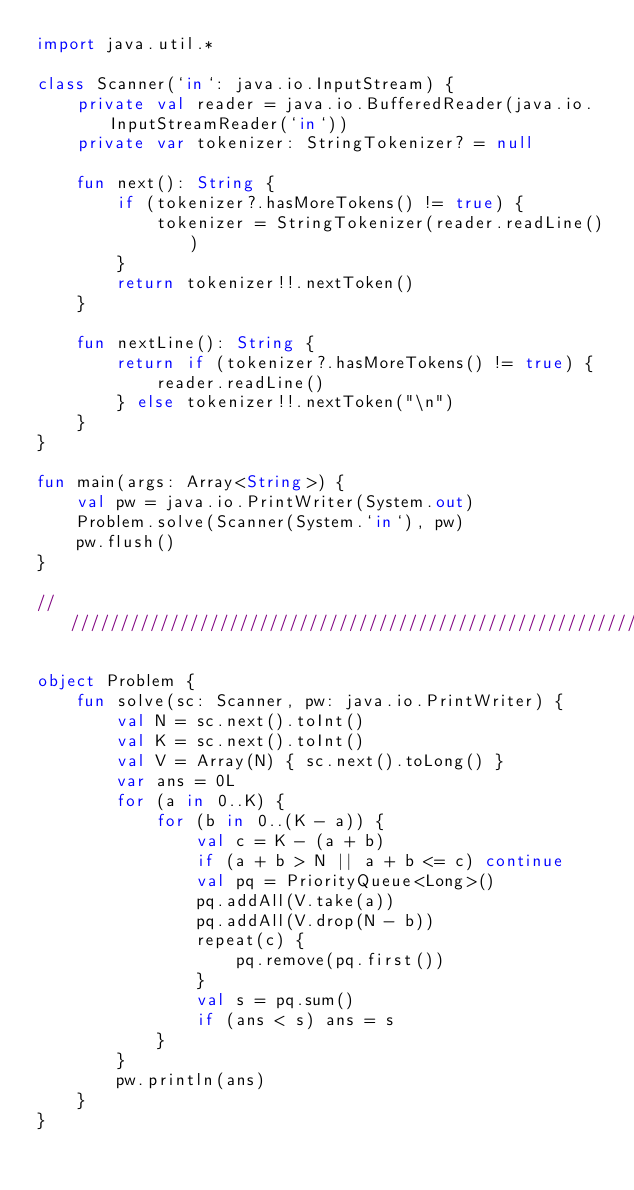<code> <loc_0><loc_0><loc_500><loc_500><_Kotlin_>import java.util.*

class Scanner(`in`: java.io.InputStream) {
    private val reader = java.io.BufferedReader(java.io.InputStreamReader(`in`))
    private var tokenizer: StringTokenizer? = null

    fun next(): String {
        if (tokenizer?.hasMoreTokens() != true) {
            tokenizer = StringTokenizer(reader.readLine())
        }
        return tokenizer!!.nextToken()
    }

    fun nextLine(): String {
        return if (tokenizer?.hasMoreTokens() != true) {
            reader.readLine()
        } else tokenizer!!.nextToken("\n")
    }
}

fun main(args: Array<String>) {
    val pw = java.io.PrintWriter(System.out)
    Problem.solve(Scanner(System.`in`), pw)
    pw.flush()
}

////////////////////////////////////////////////////////////////////////

object Problem {
    fun solve(sc: Scanner, pw: java.io.PrintWriter) {
        val N = sc.next().toInt()
        val K = sc.next().toInt()
        val V = Array(N) { sc.next().toLong() }
        var ans = 0L
        for (a in 0..K) {
            for (b in 0..(K - a)) {
                val c = K - (a + b)
                if (a + b > N || a + b <= c) continue
                val pq = PriorityQueue<Long>()
                pq.addAll(V.take(a))
                pq.addAll(V.drop(N - b))
                repeat(c) {
                    pq.remove(pq.first())
                }
                val s = pq.sum()
                if (ans < s) ans = s
            }
        }
        pw.println(ans)
    }
}
</code> 